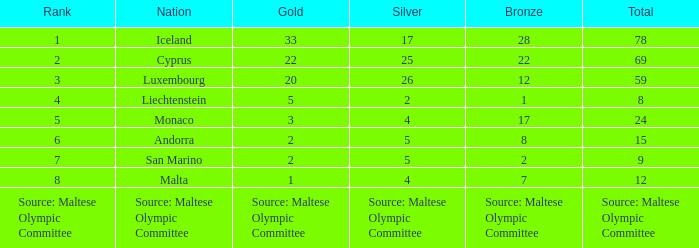What rank is the nation that has a bronze of source: Maltese Olympic Committee? Source: Maltese Olympic Committee. 